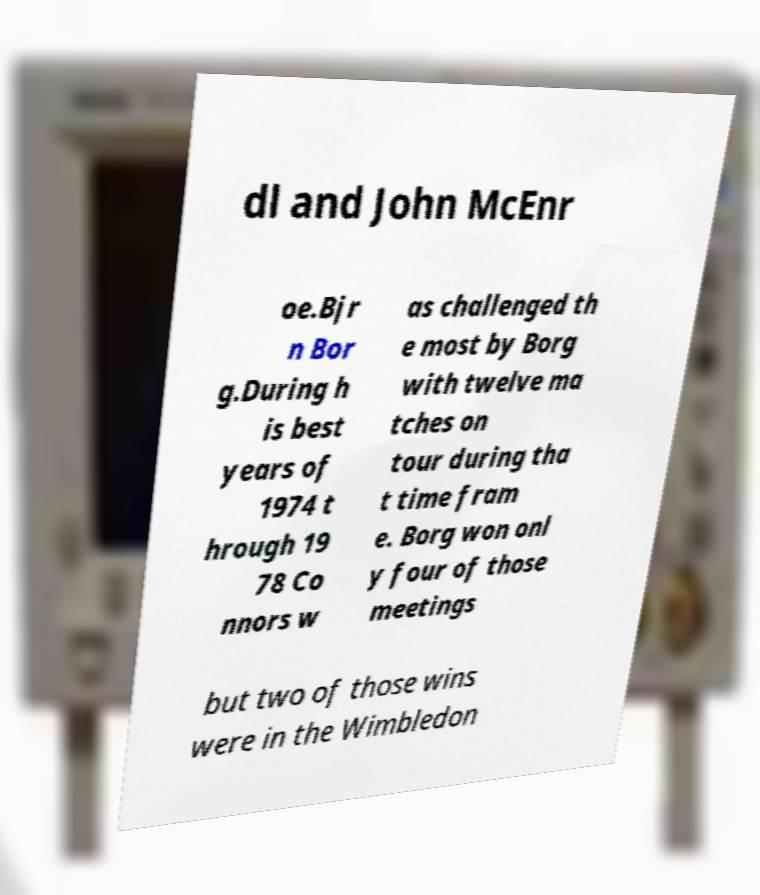Can you read and provide the text displayed in the image?This photo seems to have some interesting text. Can you extract and type it out for me? dl and John McEnr oe.Bjr n Bor g.During h is best years of 1974 t hrough 19 78 Co nnors w as challenged th e most by Borg with twelve ma tches on tour during tha t time fram e. Borg won onl y four of those meetings but two of those wins were in the Wimbledon 